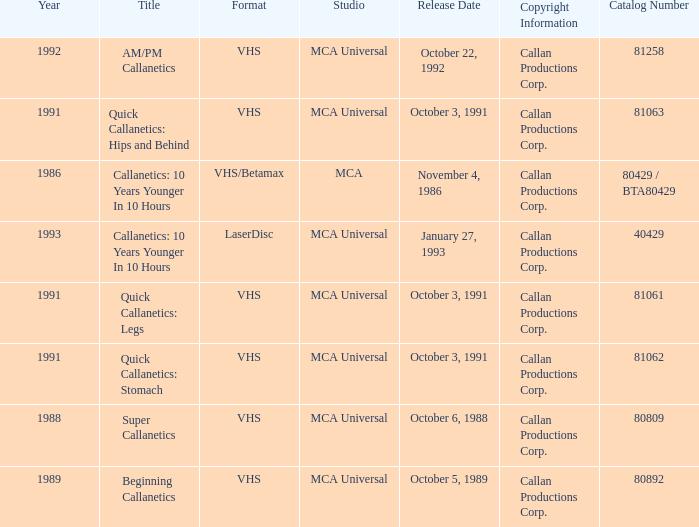Name the catalog number for  october 6, 1988 80809.0. 